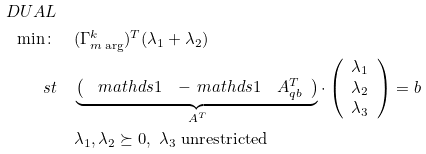Convert formula to latex. <formula><loc_0><loc_0><loc_500><loc_500>D U A L \\ \min \colon & \quad ( \Gamma ^ { k } _ { m \arg } ) ^ { T } ( \lambda _ { 1 } + \lambda _ { 2 } ) \\ \ s t & \quad \underbrace { \left ( \begin{array} { c c c } \ m a t h d s { 1 } & - \ m a t h d s { 1 } & A _ { q b } ^ { T } \end{array} \right ) } _ { A ^ { T } } \cdot \left ( \begin{array} { c } \lambda _ { 1 } \\ \lambda _ { 2 } \\ \lambda _ { 3 } \end{array} \right ) = b \\ & \quad \lambda _ { 1 } , \lambda _ { 2 } \succeq 0 , \ \lambda _ { 3 } \text { unrestricted}</formula> 